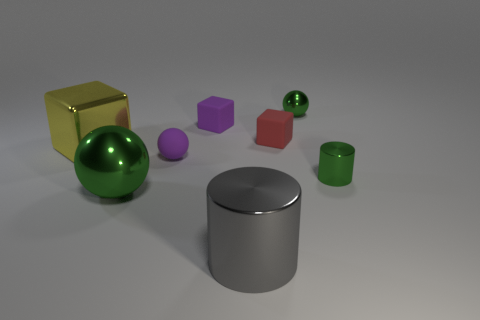What could be the potential uses for these objects if they were real? If these objects were real, they could have various applications. The cylinder could be a storage container or part of a mechanical system. The green metal ball might serve as an ornamental object or be part of a larger assembly. The cube might be a building block, either for construction or for educational purposes like a toy. These are speculative uses based on their shapes and perceived materials, as their function isn't clearly defined within the image. 